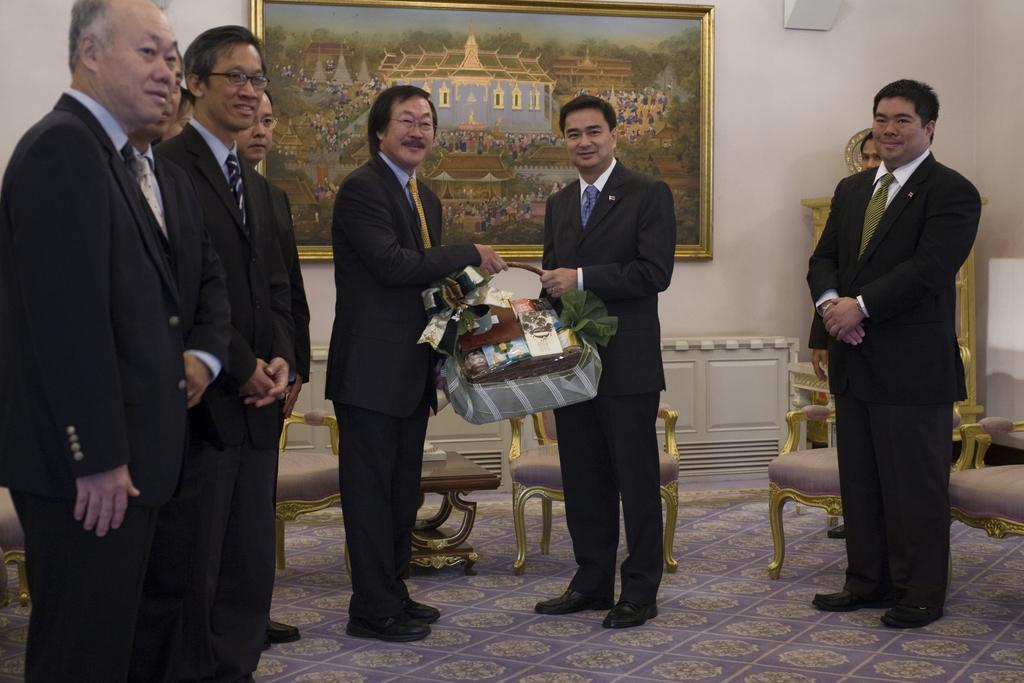What is the main subject of the image? The main subject of the image is a group of men. Where are the men located in the image? The men are standing on the floor in the image. What expression do the men have in the image? The men are smiling in the image. What type of oranges can be seen in the image? There are no oranges present in the image. What are the men learning in the image? There is no indication in the image that the men are learning anything. 